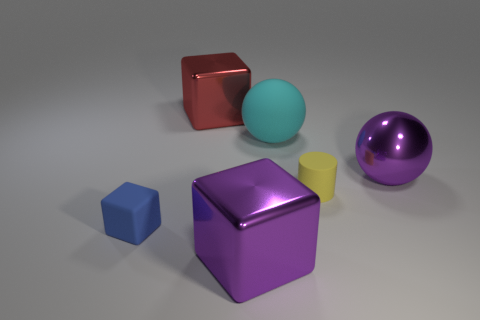Are there any other things that are the same material as the big purple block?
Offer a terse response. Yes. What number of objects are either cyan cylinders or blue matte cubes?
Your answer should be very brief. 1. There is a purple ball; is it the same size as the metallic thing that is behind the cyan sphere?
Your answer should be very brief. Yes. There is a metallic block that is behind the large block in front of the block that is behind the matte sphere; what size is it?
Provide a succinct answer. Large. Is there a rubber block?
Offer a very short reply. Yes. What material is the block that is the same color as the metal sphere?
Your answer should be compact. Metal. What number of rubber cylinders have the same color as the metallic ball?
Offer a very short reply. 0. How many objects are small matte objects that are left of the big red block or things that are in front of the purple shiny ball?
Offer a terse response. 3. What number of cyan spheres are left of the big cube behind the large purple metal block?
Ensure brevity in your answer.  0. There is a cube that is made of the same material as the red thing; what is its color?
Your answer should be very brief. Purple. 